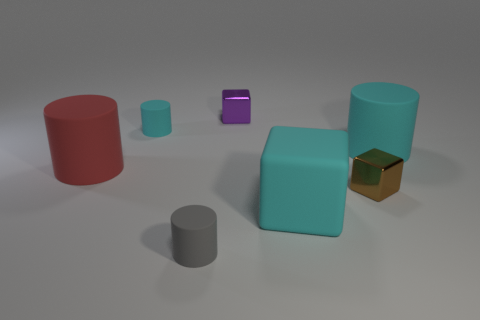Are the cylinder that is in front of the large cyan cube and the purple object made of the same material?
Your answer should be very brief. No. There is a cyan object that is both behind the small brown block and to the left of the large cyan cylinder; what material is it?
Your answer should be very brief. Rubber. What is the color of the small rubber cylinder in front of the large rubber object left of the purple block?
Your answer should be compact. Gray. What is the material of the other tiny thing that is the same shape as the tiny gray object?
Ensure brevity in your answer.  Rubber. There is a shiny cube to the right of the cyan object that is in front of the large cylinder that is right of the gray thing; what color is it?
Your response must be concise. Brown. How many objects are either tiny green balls or small cyan cylinders?
Make the answer very short. 1. What number of tiny shiny things have the same shape as the big red object?
Keep it short and to the point. 0. Is the gray object made of the same material as the cylinder left of the tiny cyan matte thing?
Provide a succinct answer. Yes. What size is the gray cylinder that is made of the same material as the big cube?
Provide a short and direct response. Small. There is a purple cube to the right of the red rubber cylinder; how big is it?
Ensure brevity in your answer.  Small. 